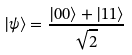Convert formula to latex. <formula><loc_0><loc_0><loc_500><loc_500>| \psi \rangle = { \frac { | 0 0 \rangle + | 1 1 \rangle } { \sqrt { 2 } } }</formula> 